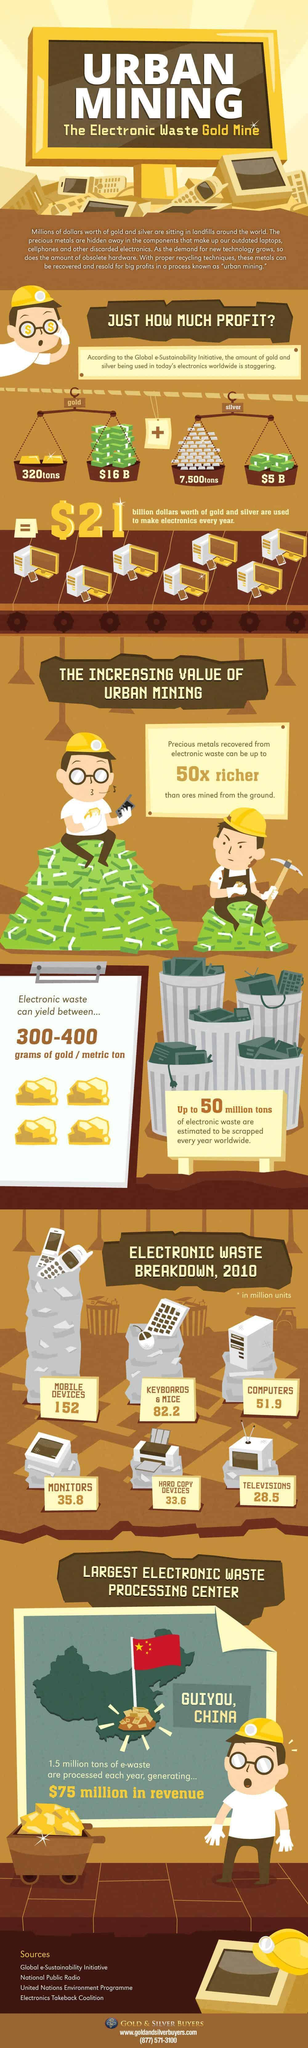How many billion dollars worth of silver is used to make electronics every year?
Answer the question with a short phrase. $5 B What amount of silver is being used in today's electronics worldwide? 7,500tons What amount of gold is being used in today's electronics worldwide? 320tons Where is the largest electronic waste processing center located in China? GUIYOU Which type of electronic waste was produced largely in 2010? MOBILE DEVICES What quantity (in million units) of computer e-waste were generated in 2010? 51.9 What quantity (in million units) of television e-waste were generated in 2010? 28.5 How many billion dollars worth of gold is used to make electronics every year? $16 B 